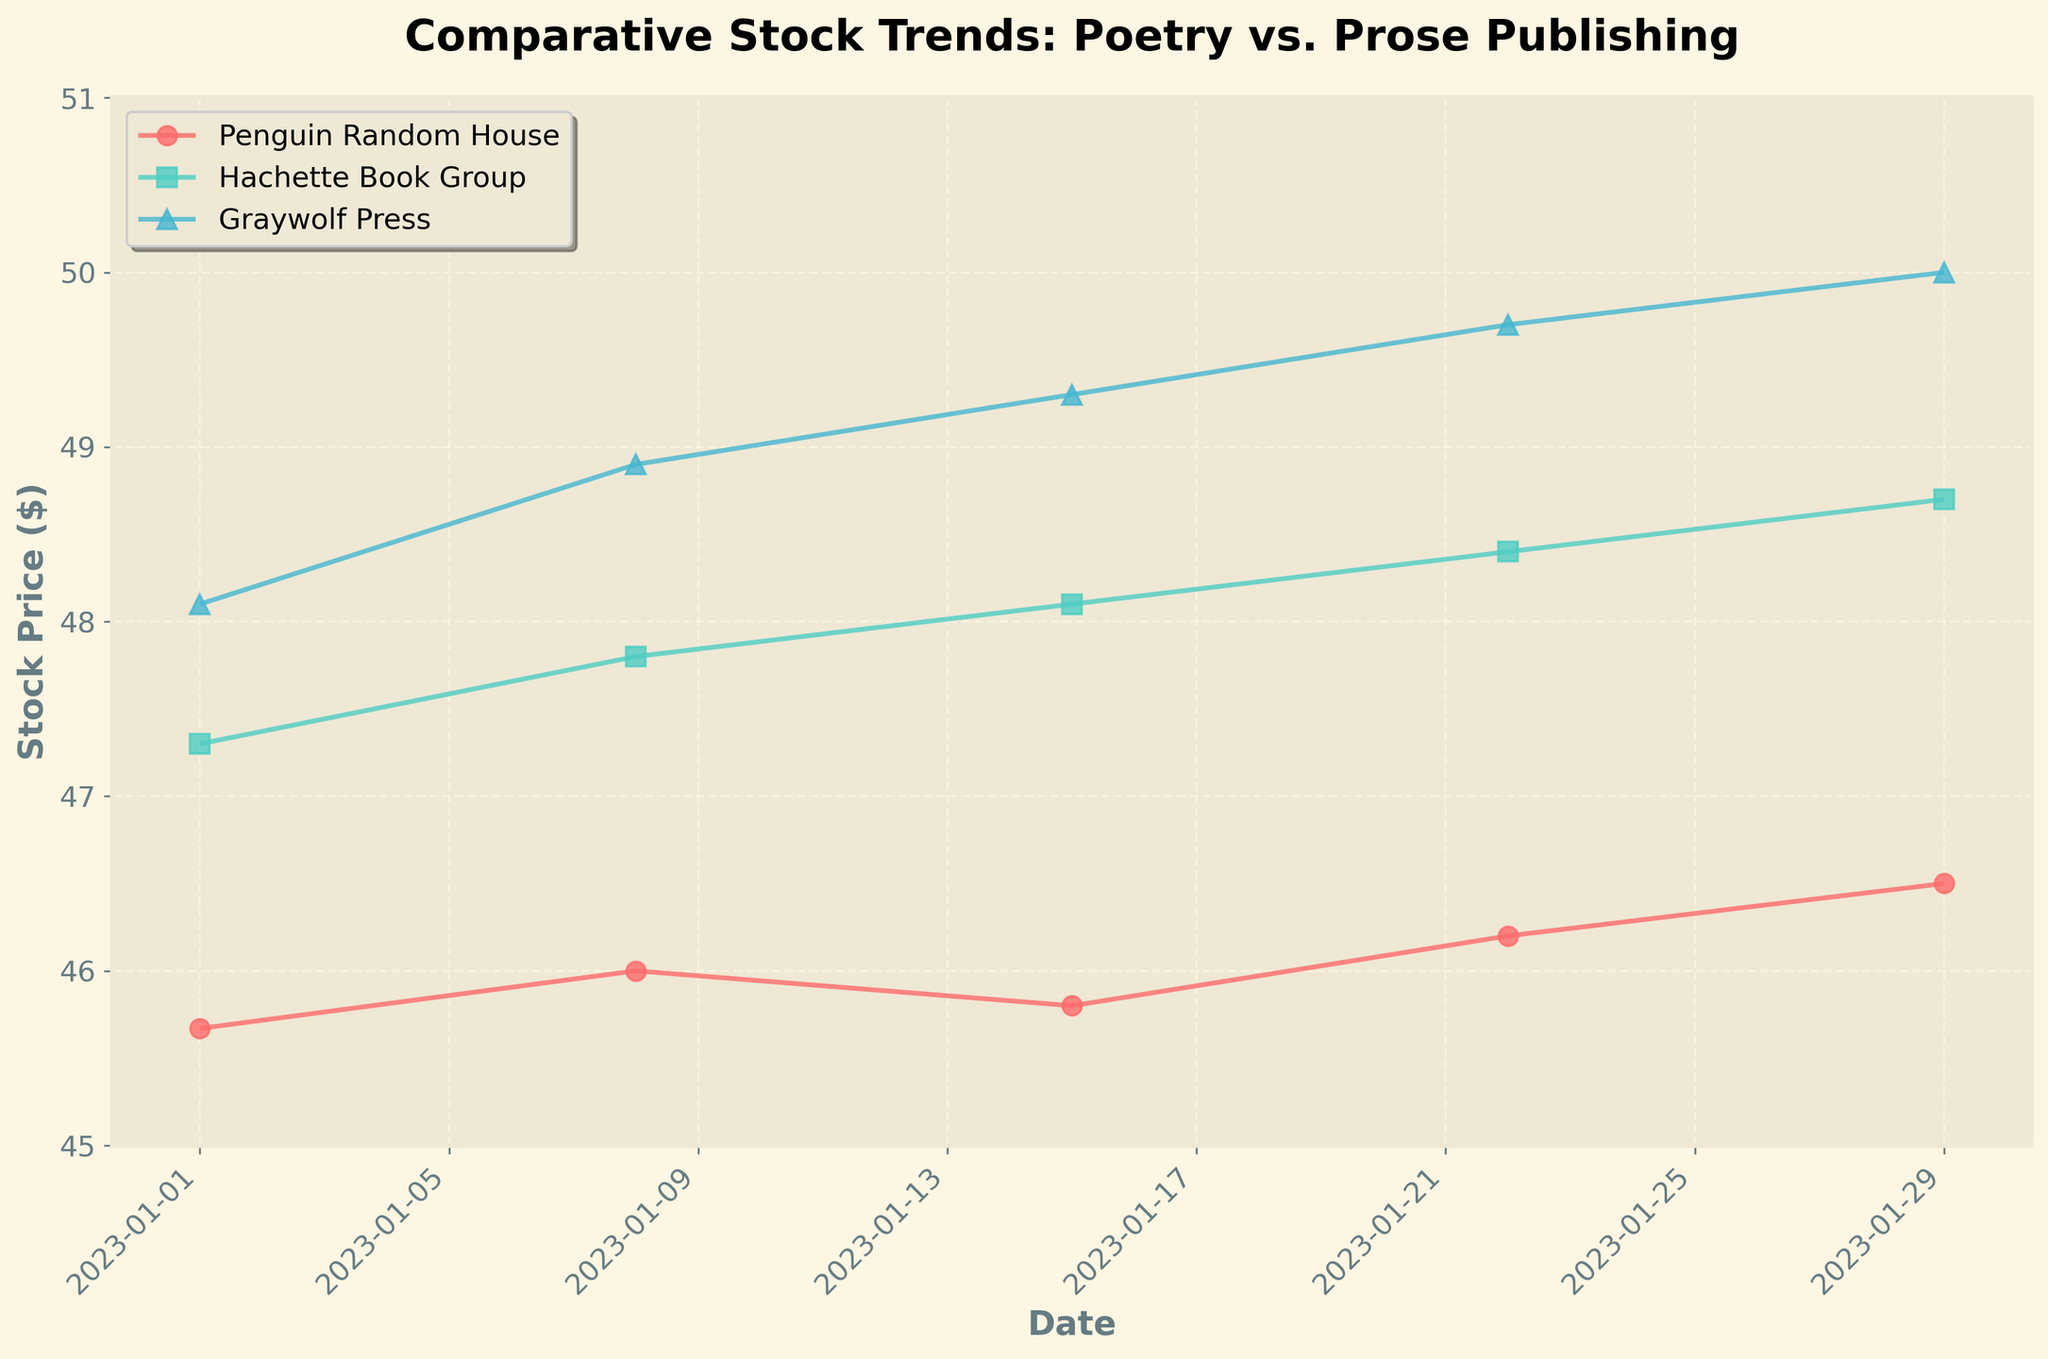what is the title of the figure? The title of the figure is displayed at the top. It reads "Comparative Stock Trends: Poetry vs. Prose Publishing".
Answer: Comparative Stock Trends: Poetry vs. Prose Publishing Between Jan 1st and Jan 29th, which company's stock price increased the most? We compare the stock prices of all companies on Jan 1st and Jan 29th. Penguin Random House went from $45.67 to $46.50, Hachette Book Group from $47.30 to $48.70, Graywolf Press from $48.10 to $50.00. Graywolf Press had the highest increase.
Answer: Graywolf Press What is the stock price trend of Graywolf Press over the weeks? Observing the markers for Graywolf Press, its stock price increased steadily. Starting from $48.10 on Jan 1st and reaching $50.00 on Jan 29th.
Answer: Increasing Compare the stock prices of Hachette Book Group and Penguin Random House on Jan 15th. Which is higher? On Jan 15th, Hachette Book Group has a stock price of $48.10, while Penguin Random House has $45.80. So, Hachette Book Group is higher.
Answer: Hachette Book Group By how much did Graywolf Press' stock price increase from Jan 1st to Jan 29th? Graywolf Press' stock price on Jan 1st was $48.10, and on Jan 29th it was $50.00. The increase is $50.00 - $48.10.
Answer: $1.90 On which date did Hachette Book Group see the highest stock price? Checking the data points for Hachette Book Group, the highest stock price is $48.70, which is on Jan 29th.
Answer: Jan 29th What was the stock price of Penguin Random House on Jan 22nd? The stock price of Penguin Random House on Jan 22nd can be read directly from the figure and it is $46.20.
Answer: $46.20 Which company's stock price has been most consistent over the weeks? Examining company trends visually, Penguin Random House's stock price seems to have the least variation, suggesting more consistency.
Answer: Penguin Random House Calculate the average stock price of Hachette Book Group over the given dates. Stock prices: $47.30, $47.80, $48.10, $48.40, $48.70. Sum is $240.30. Average is $240.30/5.
Answer: $48.06 